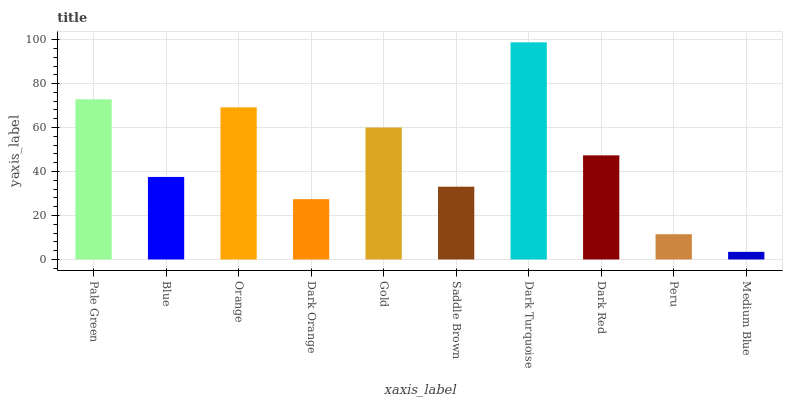Is Medium Blue the minimum?
Answer yes or no. Yes. Is Dark Turquoise the maximum?
Answer yes or no. Yes. Is Blue the minimum?
Answer yes or no. No. Is Blue the maximum?
Answer yes or no. No. Is Pale Green greater than Blue?
Answer yes or no. Yes. Is Blue less than Pale Green?
Answer yes or no. Yes. Is Blue greater than Pale Green?
Answer yes or no. No. Is Pale Green less than Blue?
Answer yes or no. No. Is Dark Red the high median?
Answer yes or no. Yes. Is Blue the low median?
Answer yes or no. Yes. Is Pale Green the high median?
Answer yes or no. No. Is Dark Orange the low median?
Answer yes or no. No. 